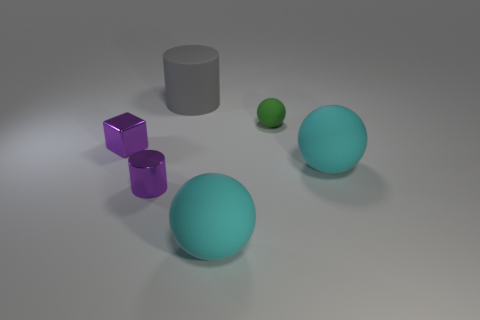Subtract all big cyan spheres. How many spheres are left? 1 Subtract all red cylinders. How many cyan spheres are left? 2 Add 1 cyan spheres. How many objects exist? 7 Subtract all cubes. How many objects are left? 5 Subtract all red spheres. Subtract all gray cubes. How many spheres are left? 3 Subtract all small purple cylinders. Subtract all big gray cylinders. How many objects are left? 4 Add 5 cyan matte balls. How many cyan matte balls are left? 7 Add 2 small blue matte cylinders. How many small blue matte cylinders exist? 2 Subtract 0 red blocks. How many objects are left? 6 